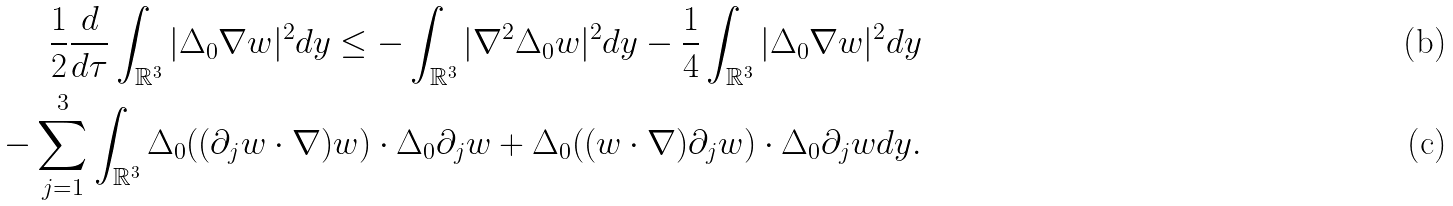<formula> <loc_0><loc_0><loc_500><loc_500>\frac { 1 } { 2 } \frac { d } { d \tau } \int _ { \mathbb { R } ^ { 3 } } | \Delta _ { 0 } \nabla w | ^ { 2 } d y \leq - \int _ { \mathbb { R } ^ { 3 } } | \nabla ^ { 2 } \Delta _ { 0 } w | ^ { 2 } d y - \frac { 1 } { 4 } \int _ { \mathbb { R } ^ { 3 } } | \Delta _ { 0 } \nabla w | ^ { 2 } d y \\ - \sum _ { j = 1 } ^ { 3 } \int _ { \mathbb { R } ^ { 3 } } \Delta _ { 0 } ( ( \partial _ { j } w \cdot \nabla ) w ) \cdot \Delta _ { 0 } \partial _ { j } w + \Delta _ { 0 } ( ( w \cdot \nabla ) \partial _ { j } w ) \cdot \Delta _ { 0 } \partial _ { j } w d y .</formula> 